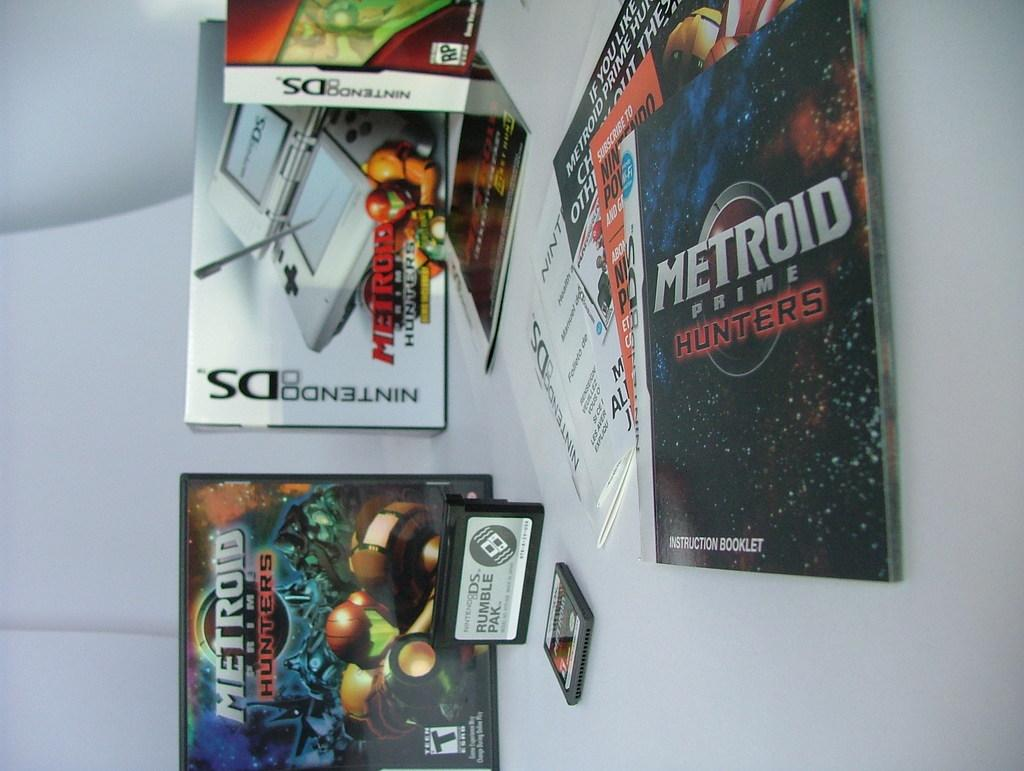Provide a one-sentence caption for the provided image. A box for Nintendo DS next to the Metroid Prime Hunters game case with the pamphlet for the game in the foreground. 